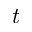<formula> <loc_0><loc_0><loc_500><loc_500>t</formula> 